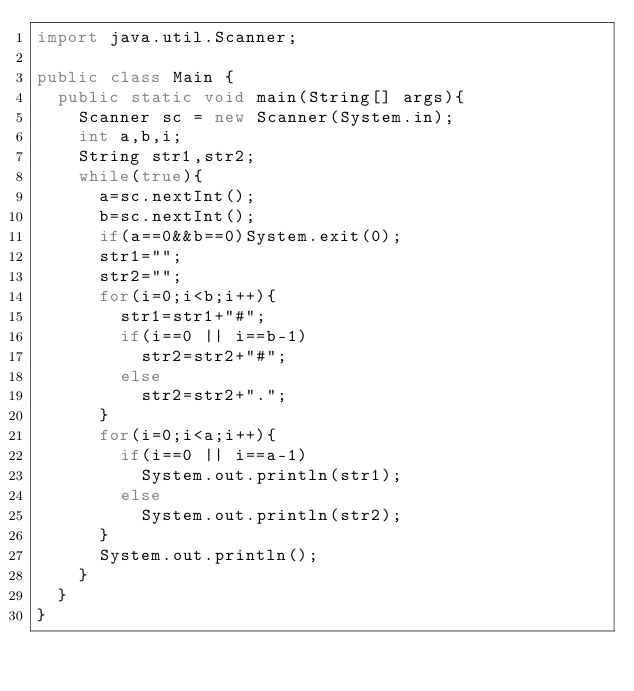Convert code to text. <code><loc_0><loc_0><loc_500><loc_500><_Java_>import java.util.Scanner;

public class Main {
	public static void main(String[] args){
		Scanner sc = new Scanner(System.in);
		int a,b,i;
		String str1,str2;
		while(true){
			a=sc.nextInt();
			b=sc.nextInt();
			if(a==0&&b==0)System.exit(0);
			str1="";
			str2="";
			for(i=0;i<b;i++){
				str1=str1+"#";
				if(i==0 || i==b-1)
					str2=str2+"#";
				else
					str2=str2+".";
			}
			for(i=0;i<a;i++){
				if(i==0 || i==a-1)
					System.out.println(str1);
				else
					System.out.println(str2);
			}
			System.out.println();
		}
	}
}
</code> 